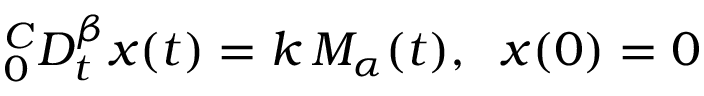<formula> <loc_0><loc_0><loc_500><loc_500>^ { C } _ { 0 } D _ { t } ^ { \beta } x ( t ) = k \, M _ { \alpha } ( t ) , \, x ( 0 ) = 0</formula> 